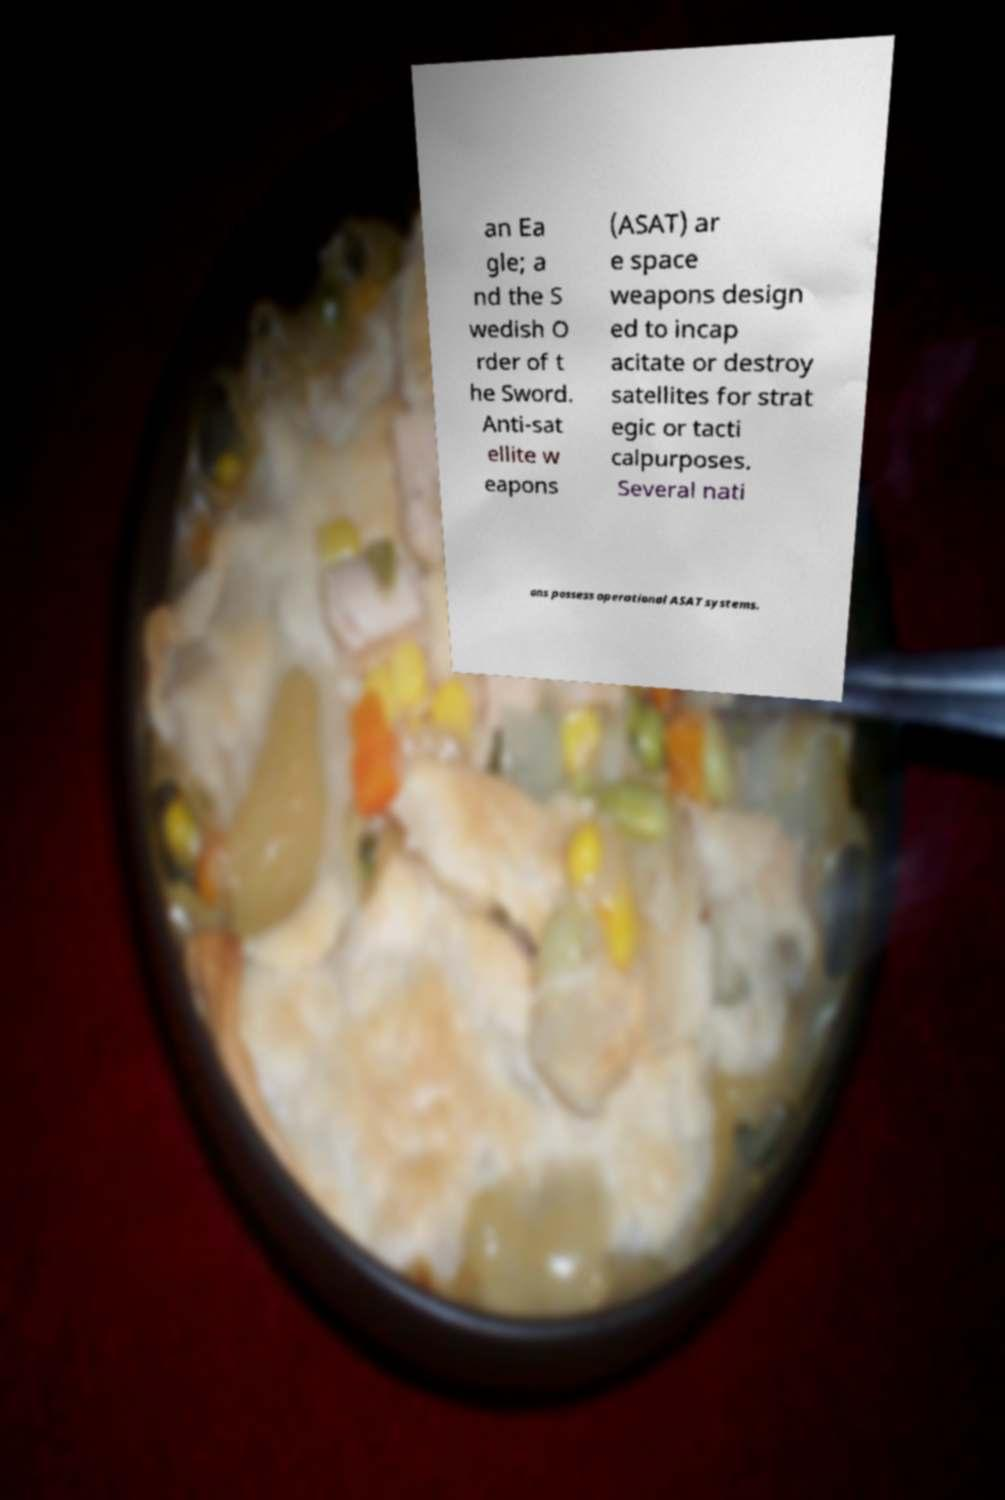Please identify and transcribe the text found in this image. an Ea gle; a nd the S wedish O rder of t he Sword. Anti-sat ellite w eapons (ASAT) ar e space weapons design ed to incap acitate or destroy satellites for strat egic or tacti calpurposes. Several nati ons possess operational ASAT systems. 